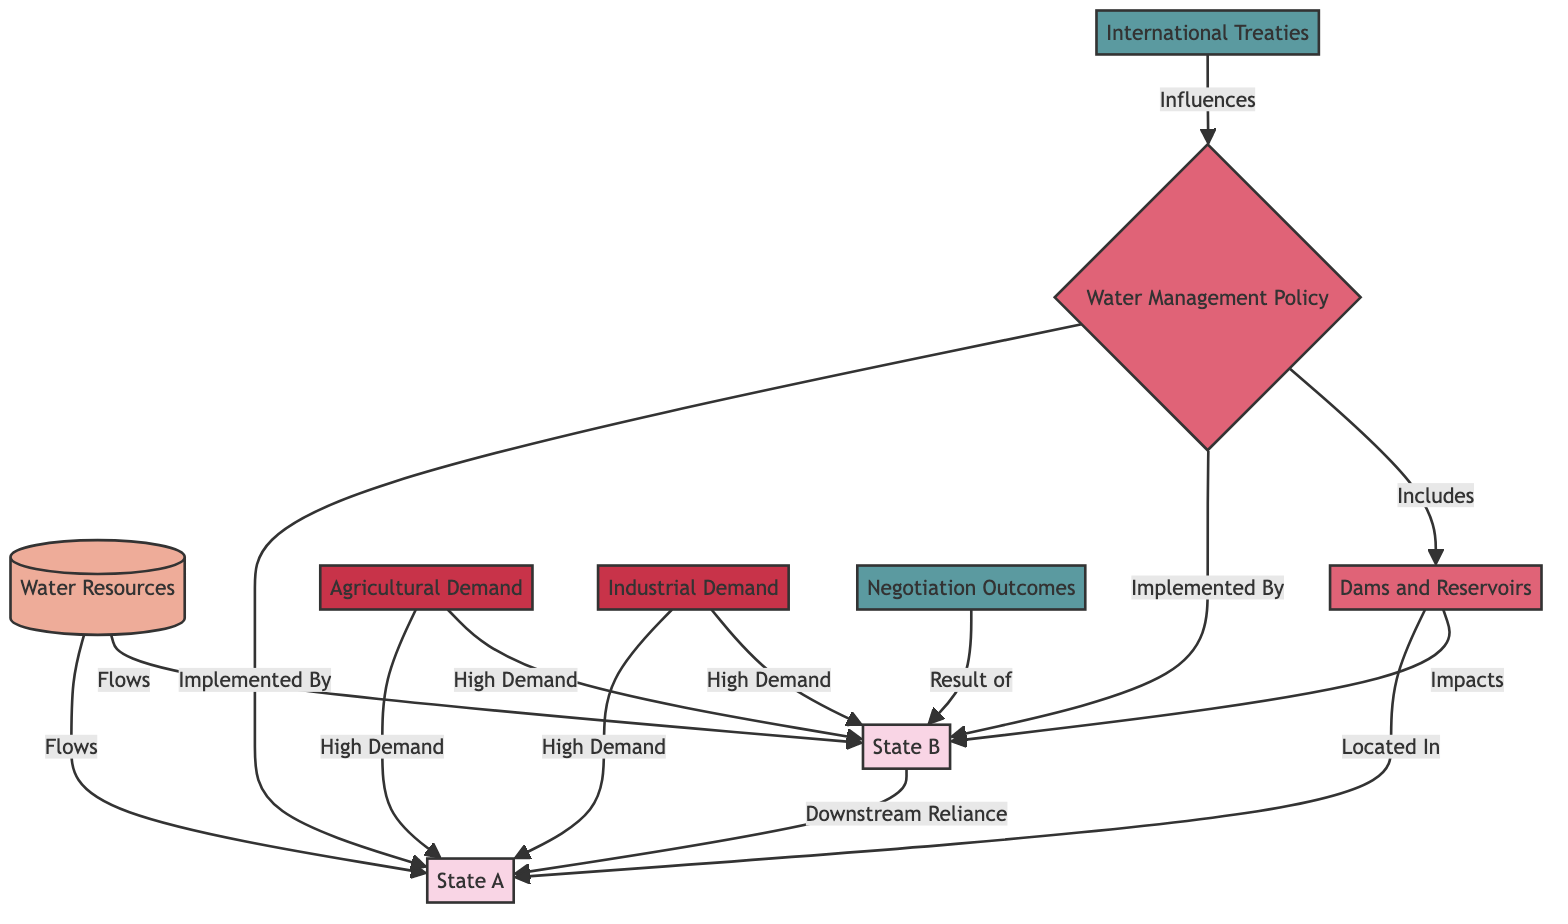What are the two states represented in the diagram? The diagram clearly identifies two states as State A and State B, which are labeled as nodes 2 and 3 respectively.
Answer: State A, State B What does State B have a reliance on? The relationship between State B and State A indicates "Downstream Reliance," which shows that State B depends on the water flow from State A.
Answer: Downstream Reliance How many water management policies are identified in the diagram? The diagram lists one primary water management policy under the node "Water Management Policy" which includes a related node for "Dams and Reservoirs."
Answer: 1 Which state has the dam and reservoirs located within its territory? According to the diagram, the node labeled "Located In" directly links "Dams and Reservoirs" to State A, indicating that they are situated within State A.
Answer: State A What influences the negotiation outcomes depicted in this diagram? The node labeled "Negotiation Outcomes" is connected to State B, with the relationship described as "Result of," meaning the outcomes are directly influenced by activities related to State B.
Answer: State B How many types of demands for water are acknowledged in the diagram? The diagram recognizes two types of water demands, which are specified as "Agricultural Demand" and "Industrial Demand."
Answer: 2 What is the impact of the dams and reservoirs on State B? The flow from "Dams and Reservoirs" towards State B is denoted by the edge "Impacts," indicating that these infrastructures have a significant effect on State B's water management.
Answer: Impacts State B Which outcome is indicated to influence the management policy? The diagram suggests that "International Treaties," which fall under the category of outcomes, influence the water management policies between the states.
Answer: International Treaties 